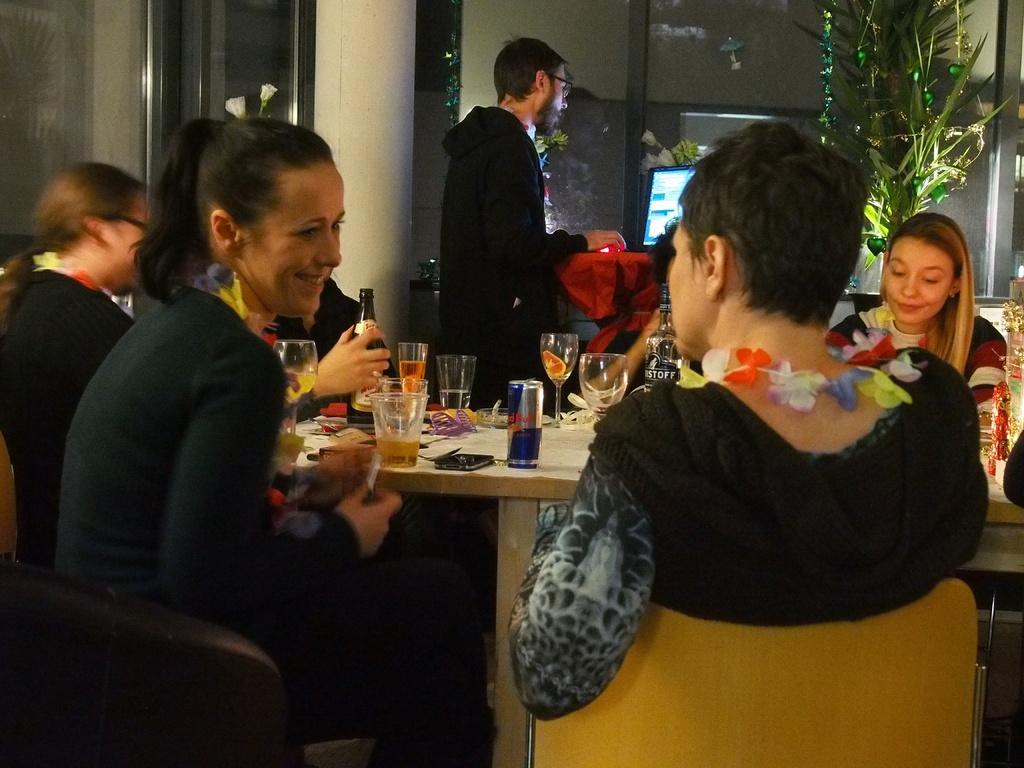Please provide a concise description of this image. In this picture there is a woman who is wearing black dress. She is sitting near to the table. On the table we can see coke can, water glass, wine glass, wine bottle, phone, papers and other objects. On the left there is another woman who is wearing black t-shirt. In the background there is a man who is looking to the television screen. Here we can see plants. On the top left corner there is a door. 